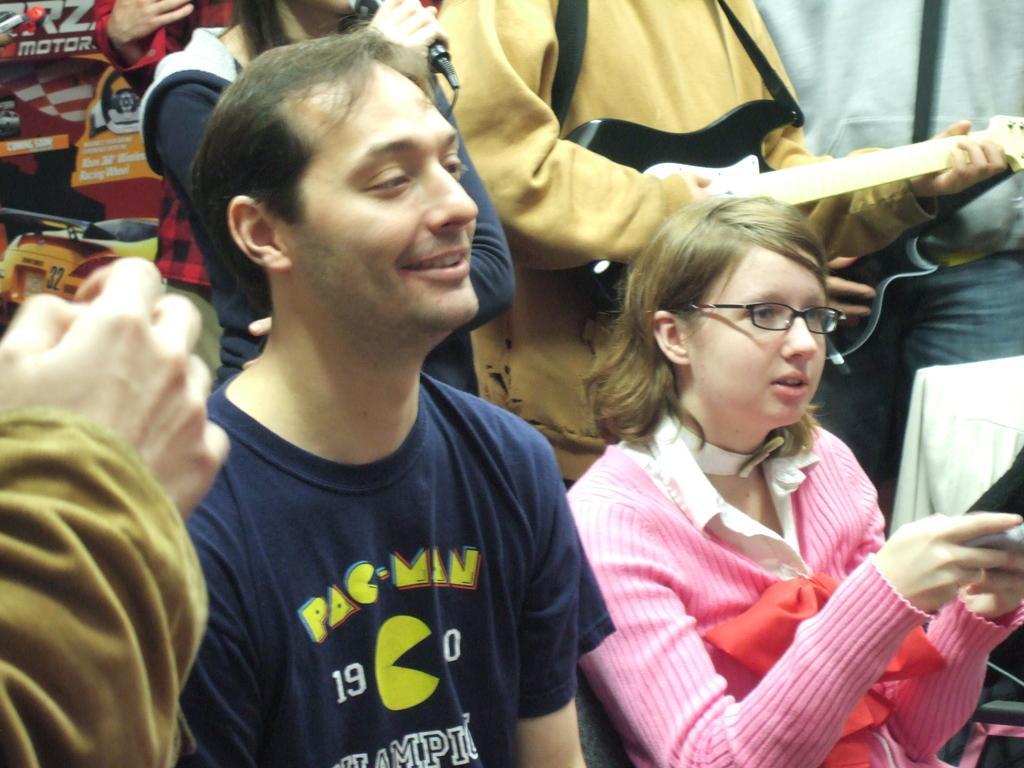Could you give a brief overview of what you see in this image? In this image in the front there are persons sitting and there is a person smiling and in the background there are persons standing and holding objects in their hands. 